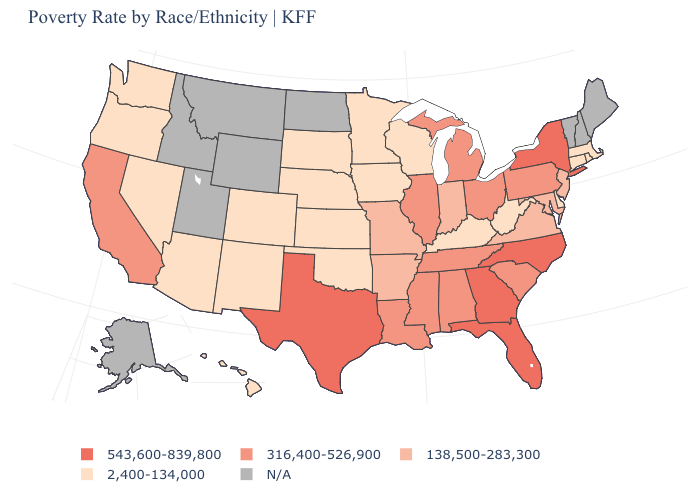What is the lowest value in states that border Nebraska?
Keep it brief. 2,400-134,000. What is the lowest value in the USA?
Quick response, please. 2,400-134,000. Name the states that have a value in the range 138,500-283,300?
Short answer required. Arkansas, Indiana, Maryland, Missouri, New Jersey, Virginia. How many symbols are there in the legend?
Short answer required. 5. Among the states that border Iowa , which have the lowest value?
Be succinct. Minnesota, Nebraska, South Dakota, Wisconsin. Name the states that have a value in the range 138,500-283,300?
Write a very short answer. Arkansas, Indiana, Maryland, Missouri, New Jersey, Virginia. What is the highest value in the MidWest ?
Quick response, please. 316,400-526,900. Which states have the lowest value in the Northeast?
Answer briefly. Connecticut, Massachusetts, Rhode Island. What is the highest value in the USA?
Concise answer only. 543,600-839,800. Name the states that have a value in the range 316,400-526,900?
Short answer required. Alabama, California, Illinois, Louisiana, Michigan, Mississippi, Ohio, Pennsylvania, South Carolina, Tennessee. What is the highest value in states that border Vermont?
Be succinct. 543,600-839,800. What is the value of Alaska?
Be succinct. N/A. What is the highest value in states that border Pennsylvania?
Answer briefly. 543,600-839,800. What is the value of Kentucky?
Quick response, please. 2,400-134,000. Name the states that have a value in the range 543,600-839,800?
Write a very short answer. Florida, Georgia, New York, North Carolina, Texas. 